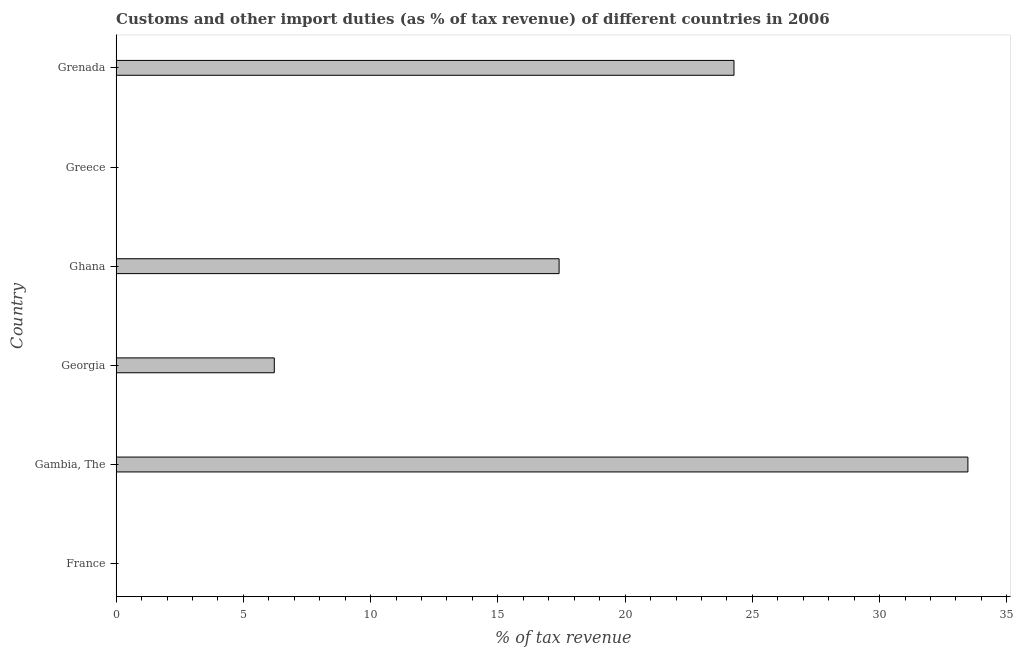What is the title of the graph?
Offer a terse response. Customs and other import duties (as % of tax revenue) of different countries in 2006. What is the label or title of the X-axis?
Give a very brief answer. % of tax revenue. What is the customs and other import duties in Georgia?
Ensure brevity in your answer.  6.22. Across all countries, what is the maximum customs and other import duties?
Offer a terse response. 33.47. In which country was the customs and other import duties maximum?
Give a very brief answer. Gambia, The. What is the sum of the customs and other import duties?
Provide a succinct answer. 81.38. What is the difference between the customs and other import duties in Gambia, The and Grenada?
Offer a terse response. 9.19. What is the average customs and other import duties per country?
Keep it short and to the point. 13.56. What is the median customs and other import duties?
Provide a succinct answer. 11.81. In how many countries, is the customs and other import duties greater than 17 %?
Your response must be concise. 3. What is the ratio of the customs and other import duties in Georgia to that in Greece?
Keep it short and to the point. 664. Is the difference between the customs and other import duties in Georgia and Greece greater than the difference between any two countries?
Your response must be concise. No. What is the difference between the highest and the second highest customs and other import duties?
Your answer should be very brief. 9.19. Is the sum of the customs and other import duties in Ghana and Greece greater than the maximum customs and other import duties across all countries?
Keep it short and to the point. No. What is the difference between the highest and the lowest customs and other import duties?
Your answer should be compact. 33.47. In how many countries, is the customs and other import duties greater than the average customs and other import duties taken over all countries?
Your answer should be compact. 3. How many bars are there?
Your answer should be very brief. 5. Are all the bars in the graph horizontal?
Make the answer very short. Yes. How many countries are there in the graph?
Your answer should be compact. 6. What is the difference between two consecutive major ticks on the X-axis?
Give a very brief answer. 5. What is the % of tax revenue of France?
Offer a very short reply. 0. What is the % of tax revenue of Gambia, The?
Your answer should be compact. 33.47. What is the % of tax revenue in Georgia?
Give a very brief answer. 6.22. What is the % of tax revenue of Ghana?
Give a very brief answer. 17.41. What is the % of tax revenue in Greece?
Provide a short and direct response. 0.01. What is the % of tax revenue of Grenada?
Make the answer very short. 24.28. What is the difference between the % of tax revenue in Gambia, The and Georgia?
Keep it short and to the point. 27.25. What is the difference between the % of tax revenue in Gambia, The and Ghana?
Ensure brevity in your answer.  16.06. What is the difference between the % of tax revenue in Gambia, The and Greece?
Your answer should be very brief. 33.46. What is the difference between the % of tax revenue in Gambia, The and Grenada?
Offer a terse response. 9.19. What is the difference between the % of tax revenue in Georgia and Ghana?
Your answer should be compact. -11.19. What is the difference between the % of tax revenue in Georgia and Greece?
Keep it short and to the point. 6.21. What is the difference between the % of tax revenue in Georgia and Grenada?
Offer a very short reply. -18.06. What is the difference between the % of tax revenue in Ghana and Greece?
Make the answer very short. 17.4. What is the difference between the % of tax revenue in Ghana and Grenada?
Provide a short and direct response. -6.87. What is the difference between the % of tax revenue in Greece and Grenada?
Offer a terse response. -24.27. What is the ratio of the % of tax revenue in Gambia, The to that in Georgia?
Offer a very short reply. 5.38. What is the ratio of the % of tax revenue in Gambia, The to that in Ghana?
Offer a terse response. 1.92. What is the ratio of the % of tax revenue in Gambia, The to that in Greece?
Make the answer very short. 3575.82. What is the ratio of the % of tax revenue in Gambia, The to that in Grenada?
Your response must be concise. 1.38. What is the ratio of the % of tax revenue in Georgia to that in Ghana?
Keep it short and to the point. 0.36. What is the ratio of the % of tax revenue in Georgia to that in Greece?
Ensure brevity in your answer.  664. What is the ratio of the % of tax revenue in Georgia to that in Grenada?
Provide a short and direct response. 0.26. What is the ratio of the % of tax revenue in Ghana to that in Greece?
Your answer should be compact. 1859.6. What is the ratio of the % of tax revenue in Ghana to that in Grenada?
Ensure brevity in your answer.  0.72. 